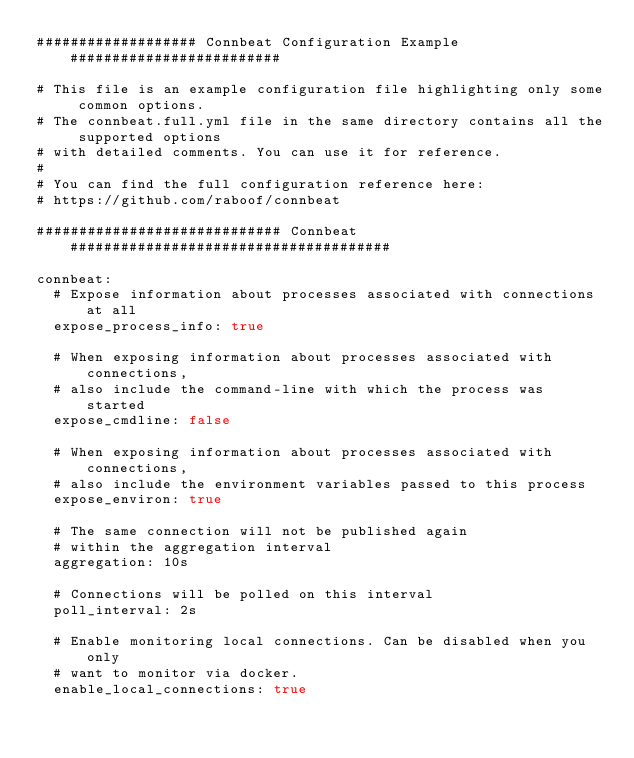Convert code to text. <code><loc_0><loc_0><loc_500><loc_500><_YAML_>################### Connbeat Configuration Example #########################

# This file is an example configuration file highlighting only some common options.
# The connbeat.full.yml file in the same directory contains all the supported options
# with detailed comments. You can use it for reference.
#
# You can find the full configuration reference here:
# https://github.com/raboof/connbeat

############################# Connbeat ######################################

connbeat:
  # Expose information about processes associated with connections at all
  expose_process_info: true

  # When exposing information about processes associated with connections,
  # also include the command-line with which the process was started
  expose_cmdline: false

  # When exposing information about processes associated with connections,
  # also include the environment variables passed to this process
  expose_environ: true

  # The same connection will not be published again
  # within the aggregation interval
  aggregation: 10s

  # Connections will be polled on this interval
  poll_interval: 2s

  # Enable monitoring local connections. Can be disabled when you only
  # want to monitor via docker.
  enable_local_connections: true
</code> 